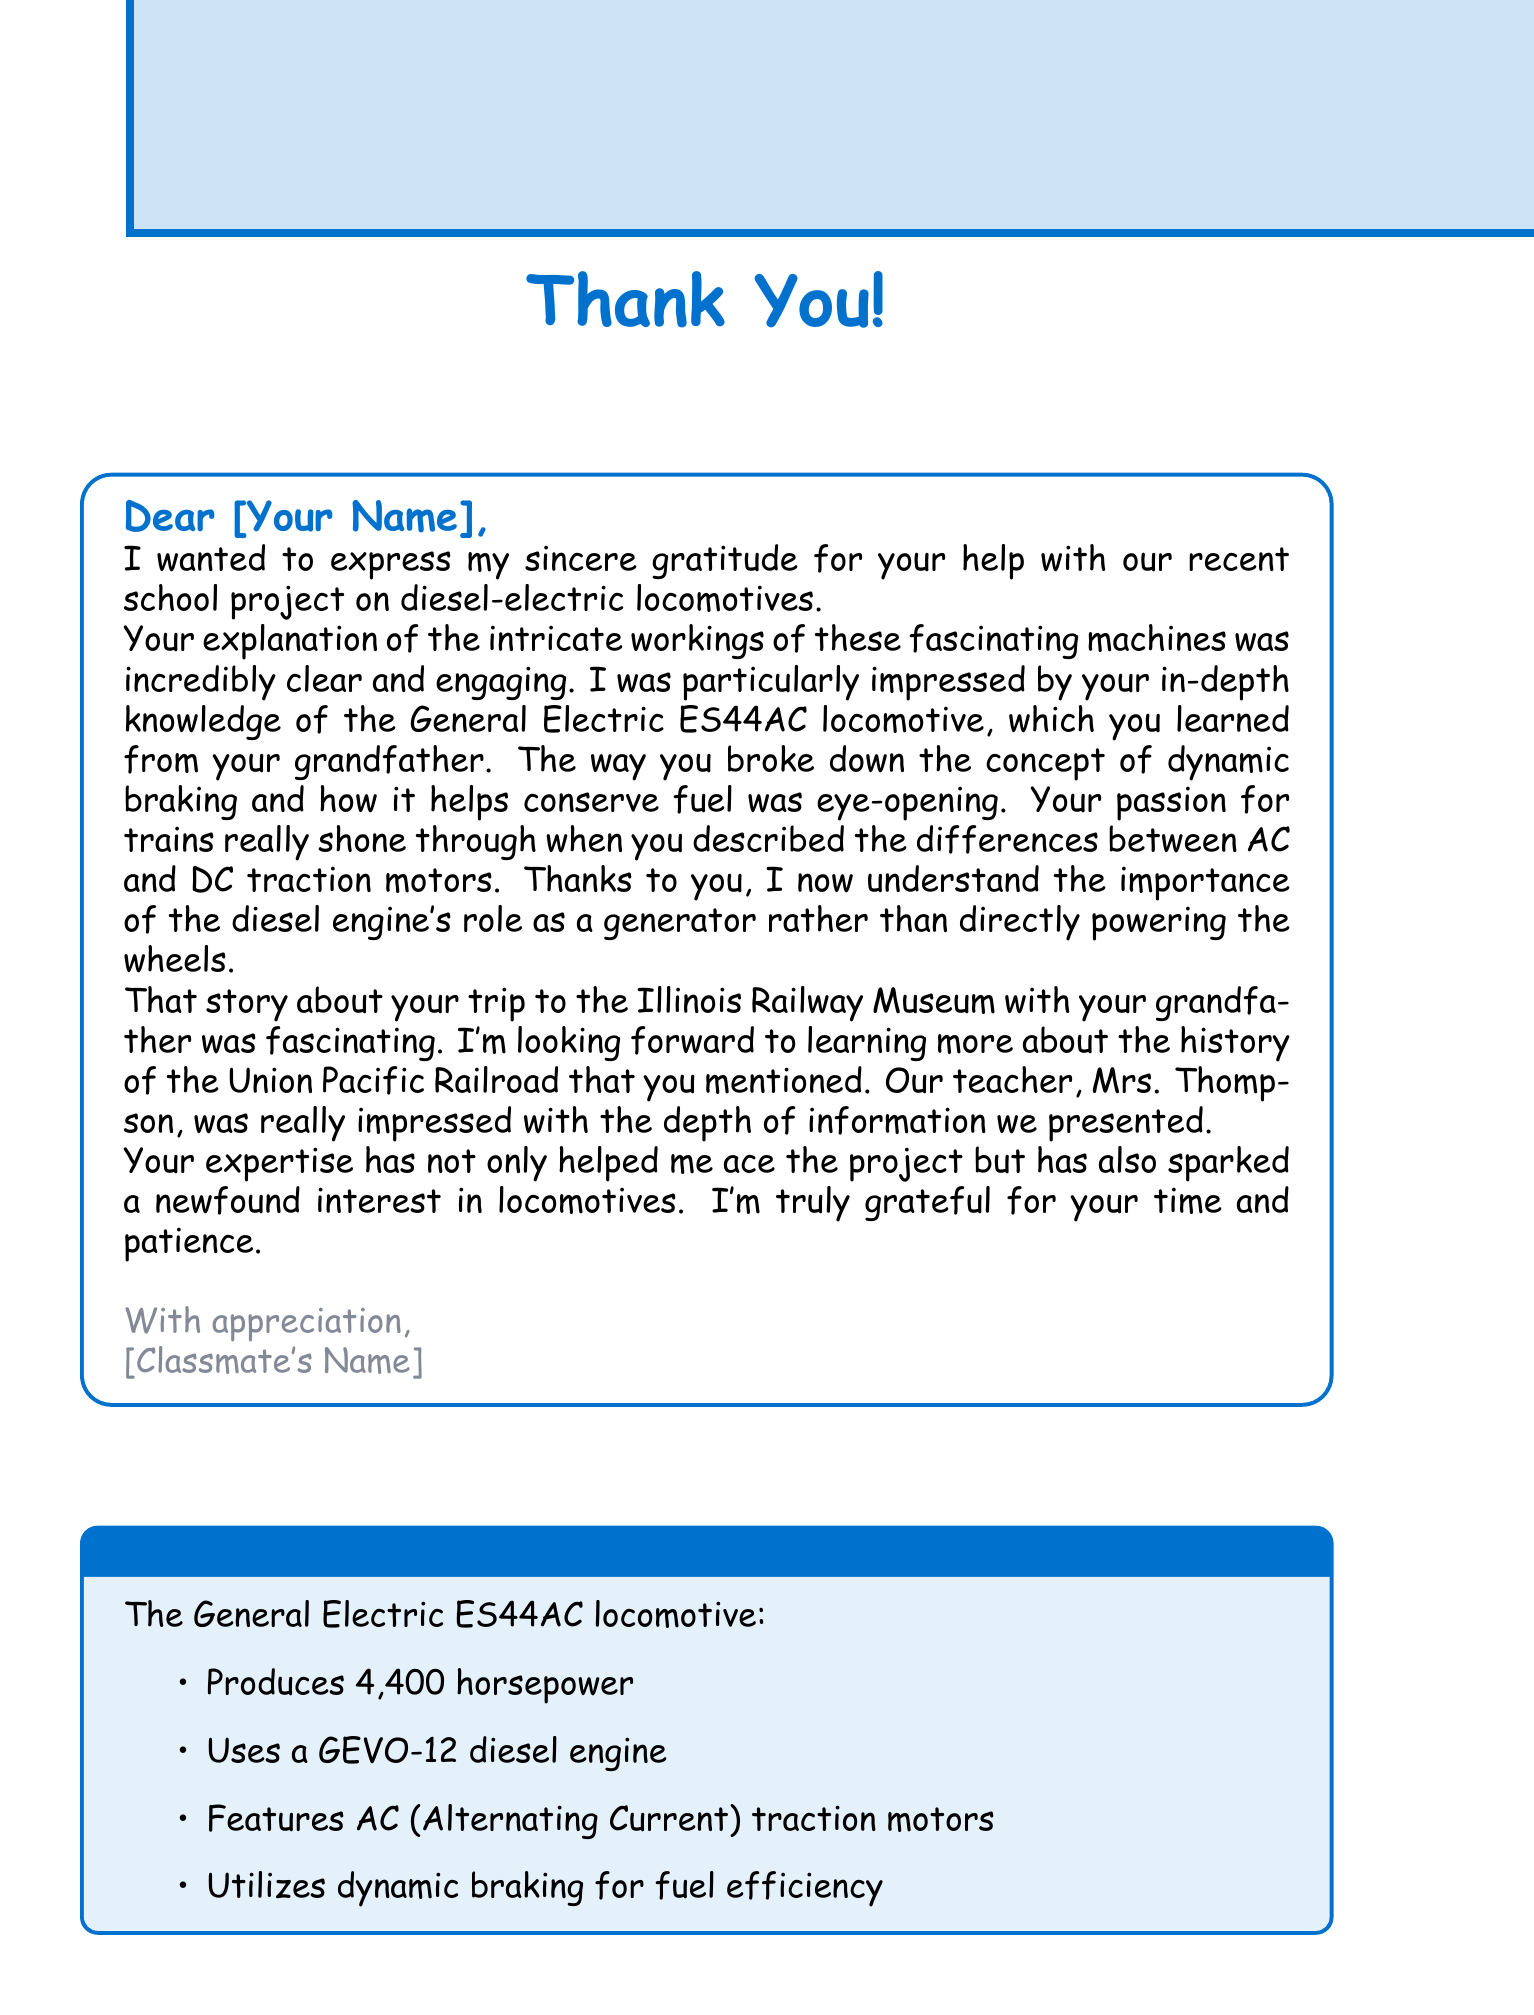What is the name of the locomotive model mentioned? The letter refers to the General Electric ES44AC, which is a specific model of diesel-electric locomotive.
Answer: General Electric ES44AC What is the power output of the General Electric ES44AC? The letter specifies that the locomotive produces a power output of 4,400 horsepower.
Answer: 4,400 horsepower Who was impressed with the project presentation? The document states that Mrs. Thompson, the teacher, was impressed with the depth of information presented about the project.
Answer: Mrs. Thompson What is the engine type used in the ES44AC locomotive? The letter mentions that the locomotive utilizes a GEVO-12 diesel engine as its engine type.
Answer: GEVO-12 diesel engine What fuel efficiency feature is discussed in the letter? The letter highlights the concept of dynamic braking as a key feature contributing to the fuel efficiency of the locomotive.
Answer: Dynamic braking What story is mentioned in the letter? The letter references a trip to the Illinois Railway Museum as a shared experience that was fascinating.
Answer: Trip to the Illinois Railway Museum What sparked the classmate's interest in locomotives? According to the letter, the expertise shared by the writer helped to spark a newfound interest in locomotives for the classmate.
Answer: Newfound interest in locomotives What differences were discussed in the letter regarding traction motors? The letter notes that the writer described the differences between AC and DC traction motors, showcasing their knowledge on the topic.
Answer: AC and DC traction motors What aspect of locomotive technology evolution was suggested as an additional topic? The document suggests exploring the evolution of locomotive technology from steam to diesel-electric as an interesting additional topic.
Answer: Evolution of locomotive technology from steam to diesel-electric 